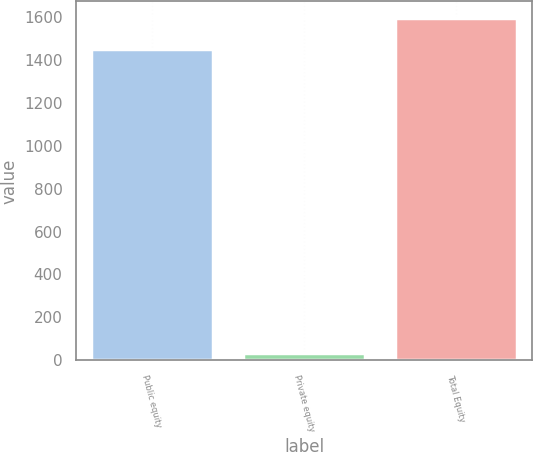Convert chart. <chart><loc_0><loc_0><loc_500><loc_500><bar_chart><fcel>Public equity<fcel>Private equity<fcel>Total Equity<nl><fcel>1448<fcel>35<fcel>1592.8<nl></chart> 